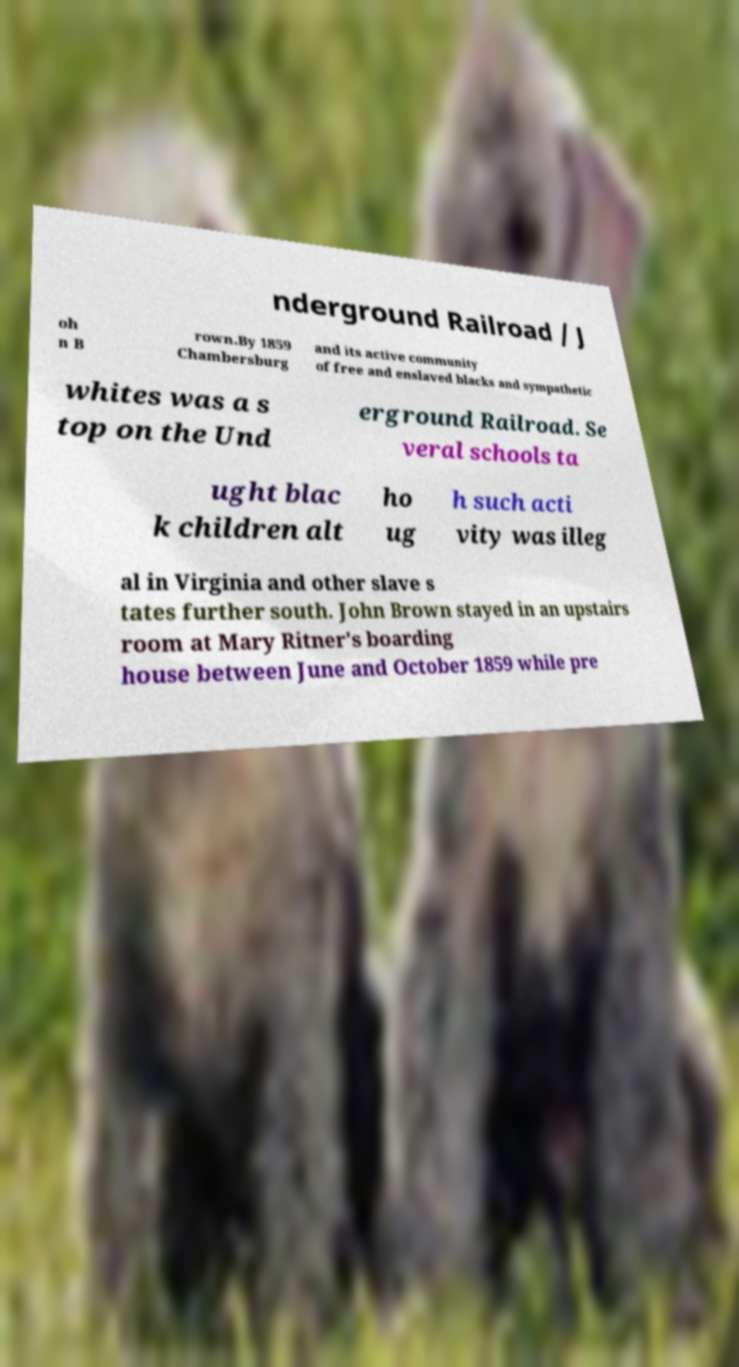Can you read and provide the text displayed in the image?This photo seems to have some interesting text. Can you extract and type it out for me? nderground Railroad / J oh n B rown.By 1859 Chambersburg and its active community of free and enslaved blacks and sympathetic whites was a s top on the Und erground Railroad. Se veral schools ta ught blac k children alt ho ug h such acti vity was illeg al in Virginia and other slave s tates further south. John Brown stayed in an upstairs room at Mary Ritner's boarding house between June and October 1859 while pre 